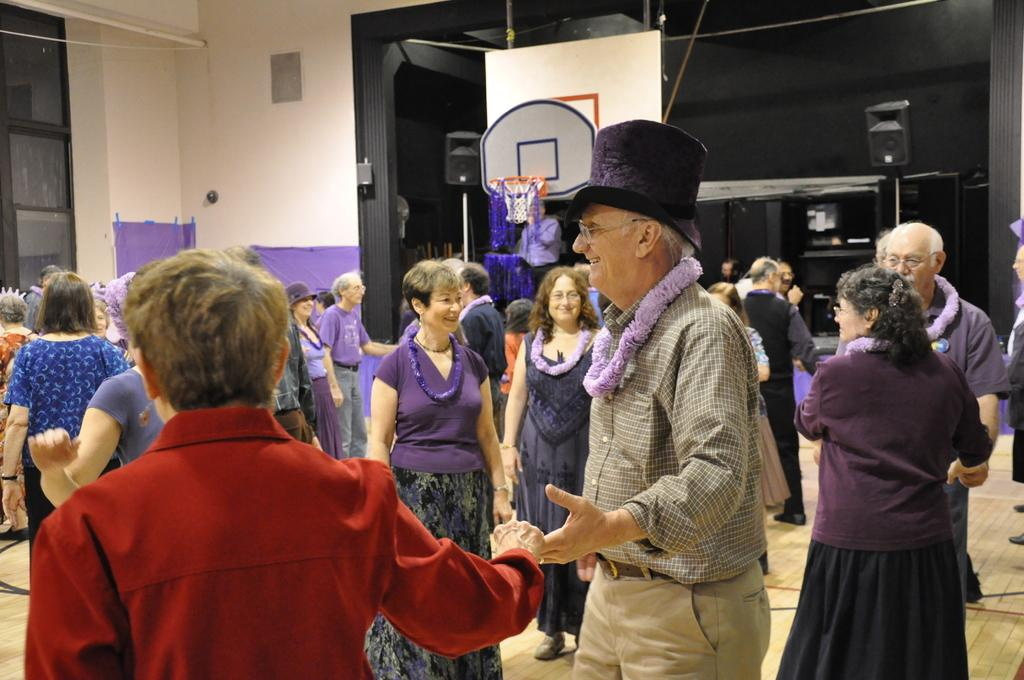What are the people in the image doing? The people in the image are dancing. Where is the dancing taking place? The dancing is taking place in a hall. What can be seen in the background of the image? There is a wall and a glass door in the background of the image. What type of silk fabric is draped over the tub in the image? There is no silk fabric or tub present in the image; it features people dancing in a hall with a wall and a glass door in the background. 